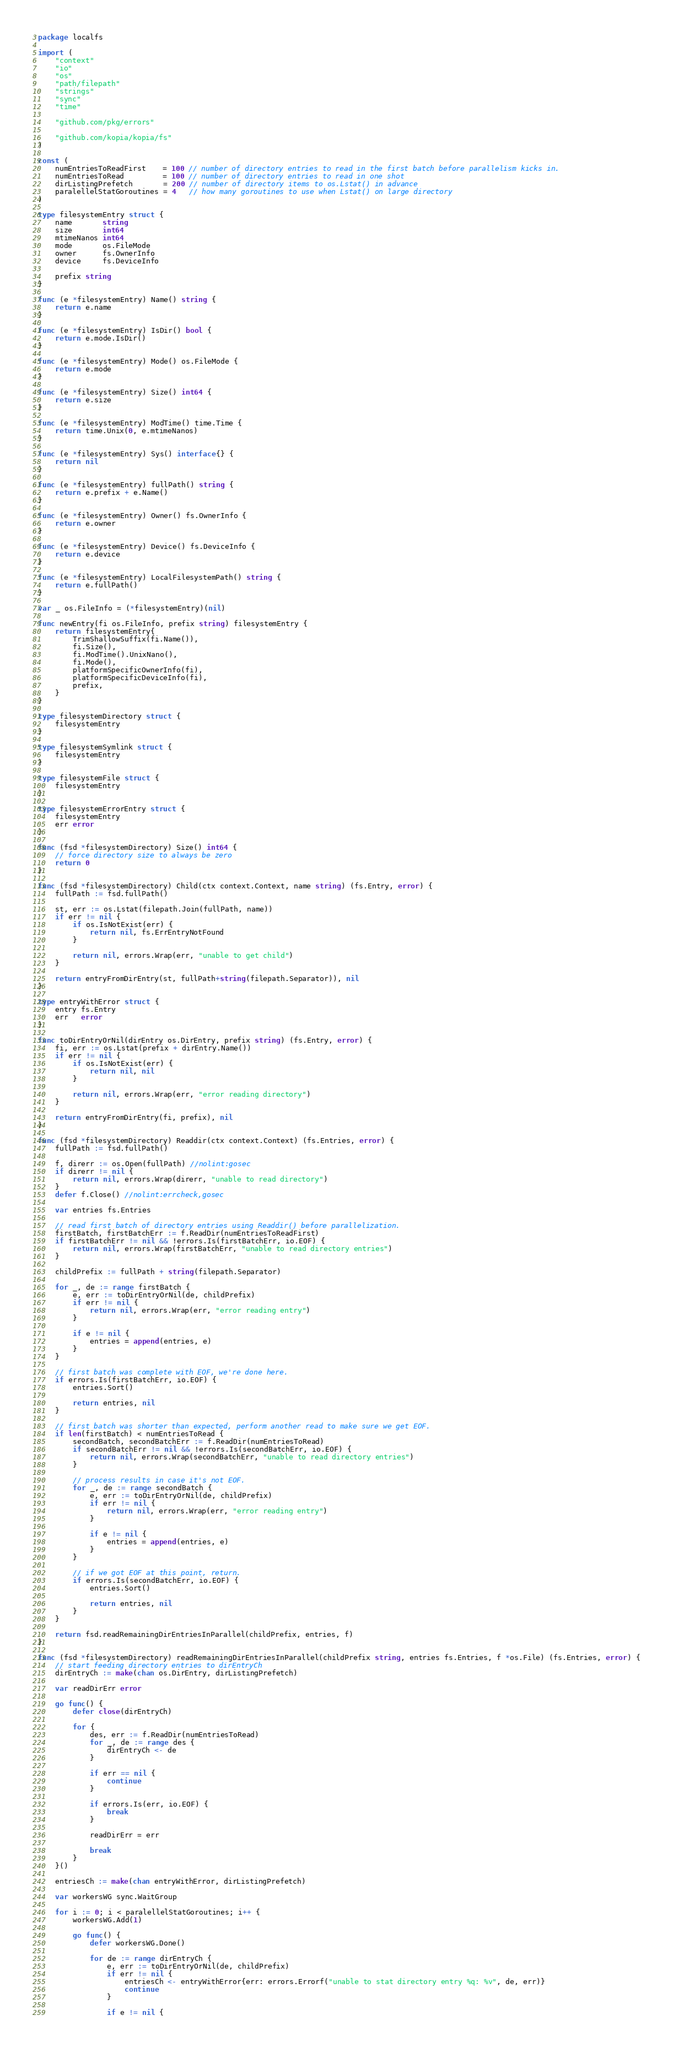<code> <loc_0><loc_0><loc_500><loc_500><_Go_>package localfs

import (
	"context"
	"io"
	"os"
	"path/filepath"
	"strings"
	"sync"
	"time"

	"github.com/pkg/errors"

	"github.com/kopia/kopia/fs"
)

const (
	numEntriesToReadFirst    = 100 // number of directory entries to read in the first batch before parallelism kicks in.
	numEntriesToRead         = 100 // number of directory entries to read in one shot
	dirListingPrefetch       = 200 // number of directory items to os.Lstat() in advance
	paralellelStatGoroutines = 4   // how many goroutines to use when Lstat() on large directory
)

type filesystemEntry struct {
	name       string
	size       int64
	mtimeNanos int64
	mode       os.FileMode
	owner      fs.OwnerInfo
	device     fs.DeviceInfo

	prefix string
}

func (e *filesystemEntry) Name() string {
	return e.name
}

func (e *filesystemEntry) IsDir() bool {
	return e.mode.IsDir()
}

func (e *filesystemEntry) Mode() os.FileMode {
	return e.mode
}

func (e *filesystemEntry) Size() int64 {
	return e.size
}

func (e *filesystemEntry) ModTime() time.Time {
	return time.Unix(0, e.mtimeNanos)
}

func (e *filesystemEntry) Sys() interface{} {
	return nil
}

func (e *filesystemEntry) fullPath() string {
	return e.prefix + e.Name()
}

func (e *filesystemEntry) Owner() fs.OwnerInfo {
	return e.owner
}

func (e *filesystemEntry) Device() fs.DeviceInfo {
	return e.device
}

func (e *filesystemEntry) LocalFilesystemPath() string {
	return e.fullPath()
}

var _ os.FileInfo = (*filesystemEntry)(nil)

func newEntry(fi os.FileInfo, prefix string) filesystemEntry {
	return filesystemEntry{
		TrimShallowSuffix(fi.Name()),
		fi.Size(),
		fi.ModTime().UnixNano(),
		fi.Mode(),
		platformSpecificOwnerInfo(fi),
		platformSpecificDeviceInfo(fi),
		prefix,
	}
}

type filesystemDirectory struct {
	filesystemEntry
}

type filesystemSymlink struct {
	filesystemEntry
}

type filesystemFile struct {
	filesystemEntry
}

type filesystemErrorEntry struct {
	filesystemEntry
	err error
}

func (fsd *filesystemDirectory) Size() int64 {
	// force directory size to always be zero
	return 0
}

func (fsd *filesystemDirectory) Child(ctx context.Context, name string) (fs.Entry, error) {
	fullPath := fsd.fullPath()

	st, err := os.Lstat(filepath.Join(fullPath, name))
	if err != nil {
		if os.IsNotExist(err) {
			return nil, fs.ErrEntryNotFound
		}

		return nil, errors.Wrap(err, "unable to get child")
	}

	return entryFromDirEntry(st, fullPath+string(filepath.Separator)), nil
}

type entryWithError struct {
	entry fs.Entry
	err   error
}

func toDirEntryOrNil(dirEntry os.DirEntry, prefix string) (fs.Entry, error) {
	fi, err := os.Lstat(prefix + dirEntry.Name())
	if err != nil {
		if os.IsNotExist(err) {
			return nil, nil
		}

		return nil, errors.Wrap(err, "error reading directory")
	}

	return entryFromDirEntry(fi, prefix), nil
}

func (fsd *filesystemDirectory) Readdir(ctx context.Context) (fs.Entries, error) {
	fullPath := fsd.fullPath()

	f, direrr := os.Open(fullPath) //nolint:gosec
	if direrr != nil {
		return nil, errors.Wrap(direrr, "unable to read directory")
	}
	defer f.Close() //nolint:errcheck,gosec

	var entries fs.Entries

	// read first batch of directory entries using Readdir() before parallelization.
	firstBatch, firstBatchErr := f.ReadDir(numEntriesToReadFirst)
	if firstBatchErr != nil && !errors.Is(firstBatchErr, io.EOF) {
		return nil, errors.Wrap(firstBatchErr, "unable to read directory entries")
	}

	childPrefix := fullPath + string(filepath.Separator)

	for _, de := range firstBatch {
		e, err := toDirEntryOrNil(de, childPrefix)
		if err != nil {
			return nil, errors.Wrap(err, "error reading entry")
		}

		if e != nil {
			entries = append(entries, e)
		}
	}

	// first batch was complete with EOF, we're done here.
	if errors.Is(firstBatchErr, io.EOF) {
		entries.Sort()

		return entries, nil
	}

	// first batch was shorter than expected, perform another read to make sure we get EOF.
	if len(firstBatch) < numEntriesToRead {
		secondBatch, secondBatchErr := f.ReadDir(numEntriesToRead)
		if secondBatchErr != nil && !errors.Is(secondBatchErr, io.EOF) {
			return nil, errors.Wrap(secondBatchErr, "unable to read directory entries")
		}

		// process results in case it's not EOF.
		for _, de := range secondBatch {
			e, err := toDirEntryOrNil(de, childPrefix)
			if err != nil {
				return nil, errors.Wrap(err, "error reading entry")
			}

			if e != nil {
				entries = append(entries, e)
			}
		}

		// if we got EOF at this point, return.
		if errors.Is(secondBatchErr, io.EOF) {
			entries.Sort()

			return entries, nil
		}
	}

	return fsd.readRemainingDirEntriesInParallel(childPrefix, entries, f)
}

func (fsd *filesystemDirectory) readRemainingDirEntriesInParallel(childPrefix string, entries fs.Entries, f *os.File) (fs.Entries, error) {
	// start feeding directory entries to dirEntryCh
	dirEntryCh := make(chan os.DirEntry, dirListingPrefetch)

	var readDirErr error

	go func() {
		defer close(dirEntryCh)

		for {
			des, err := f.ReadDir(numEntriesToRead)
			for _, de := range des {
				dirEntryCh <- de
			}

			if err == nil {
				continue
			}

			if errors.Is(err, io.EOF) {
				break
			}

			readDirErr = err

			break
		}
	}()

	entriesCh := make(chan entryWithError, dirListingPrefetch)

	var workersWG sync.WaitGroup

	for i := 0; i < paralellelStatGoroutines; i++ {
		workersWG.Add(1)

		go func() {
			defer workersWG.Done()

			for de := range dirEntryCh {
				e, err := toDirEntryOrNil(de, childPrefix)
				if err != nil {
					entriesCh <- entryWithError{err: errors.Errorf("unable to stat directory entry %q: %v", de, err)}
					continue
				}

				if e != nil {</code> 